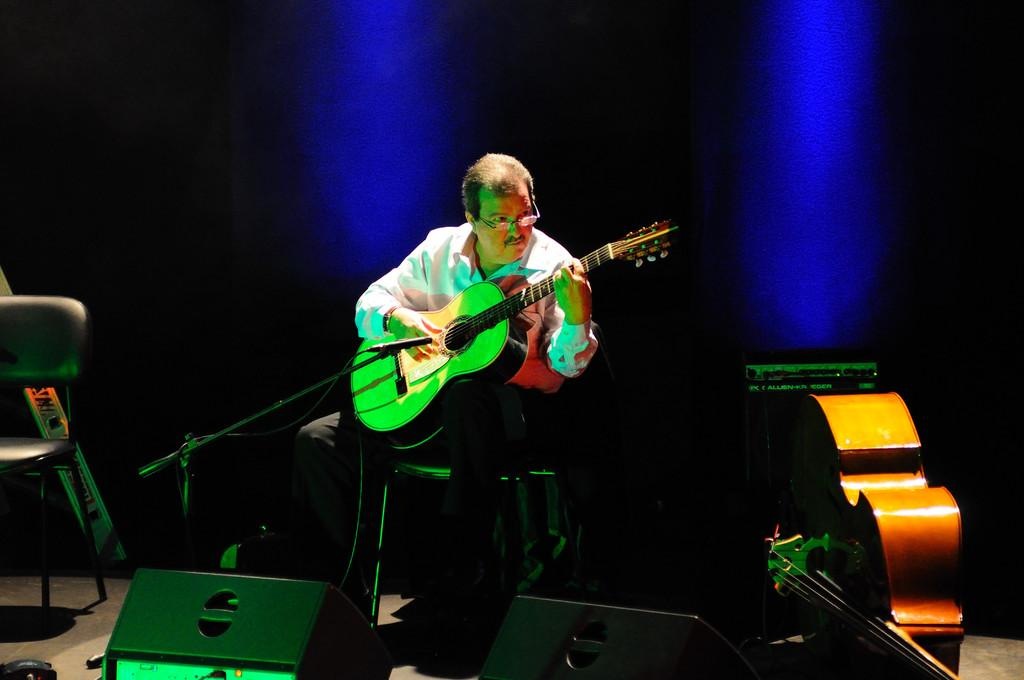Who is the main subject in the image? There is a man in the image. What is the man doing in the image? The man is sitting on a chair and holding a guitar. What object is in front of the man? There is a microphone in front of the man. What type of underwear is the man wearing in the image? There is no information about the man's underwear in the image, so we cannot determine what type he is wearing. Is the man crying in the image? There is no indication that the man is crying in the image; he appears to be focused on holding the guitar. 